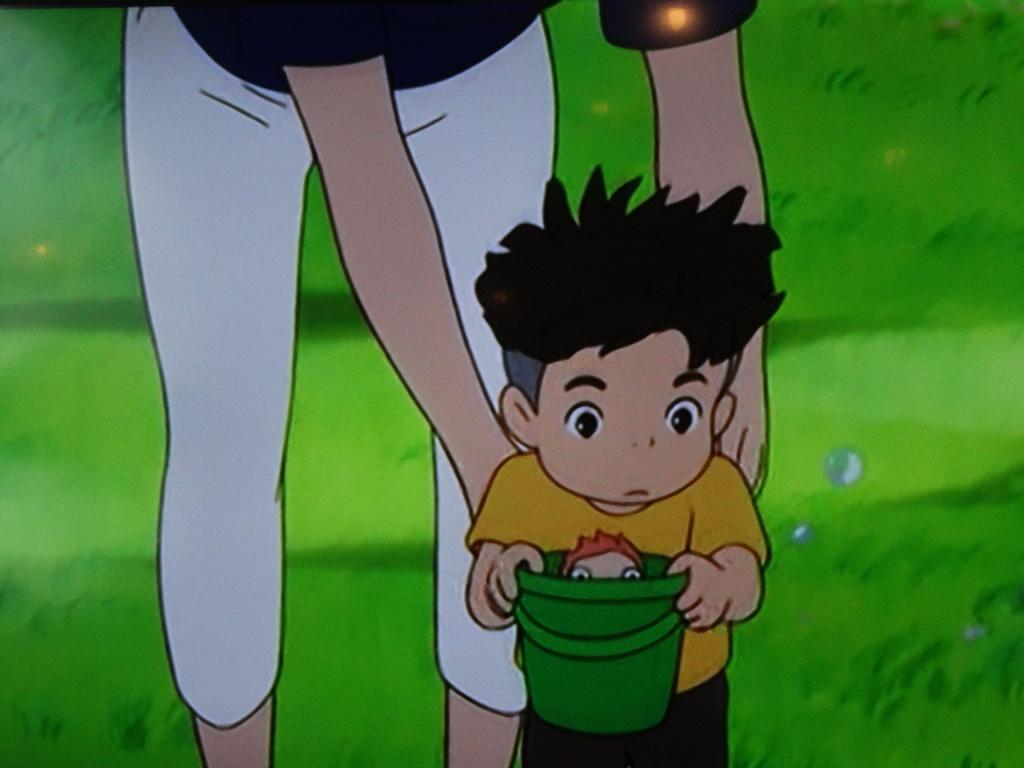In one or two sentences, can you explain what this image depicts? In this image there is a cartoon of a person and a child holding bucket, in the bucket there is a toy or a person. In the background there is a grass. 